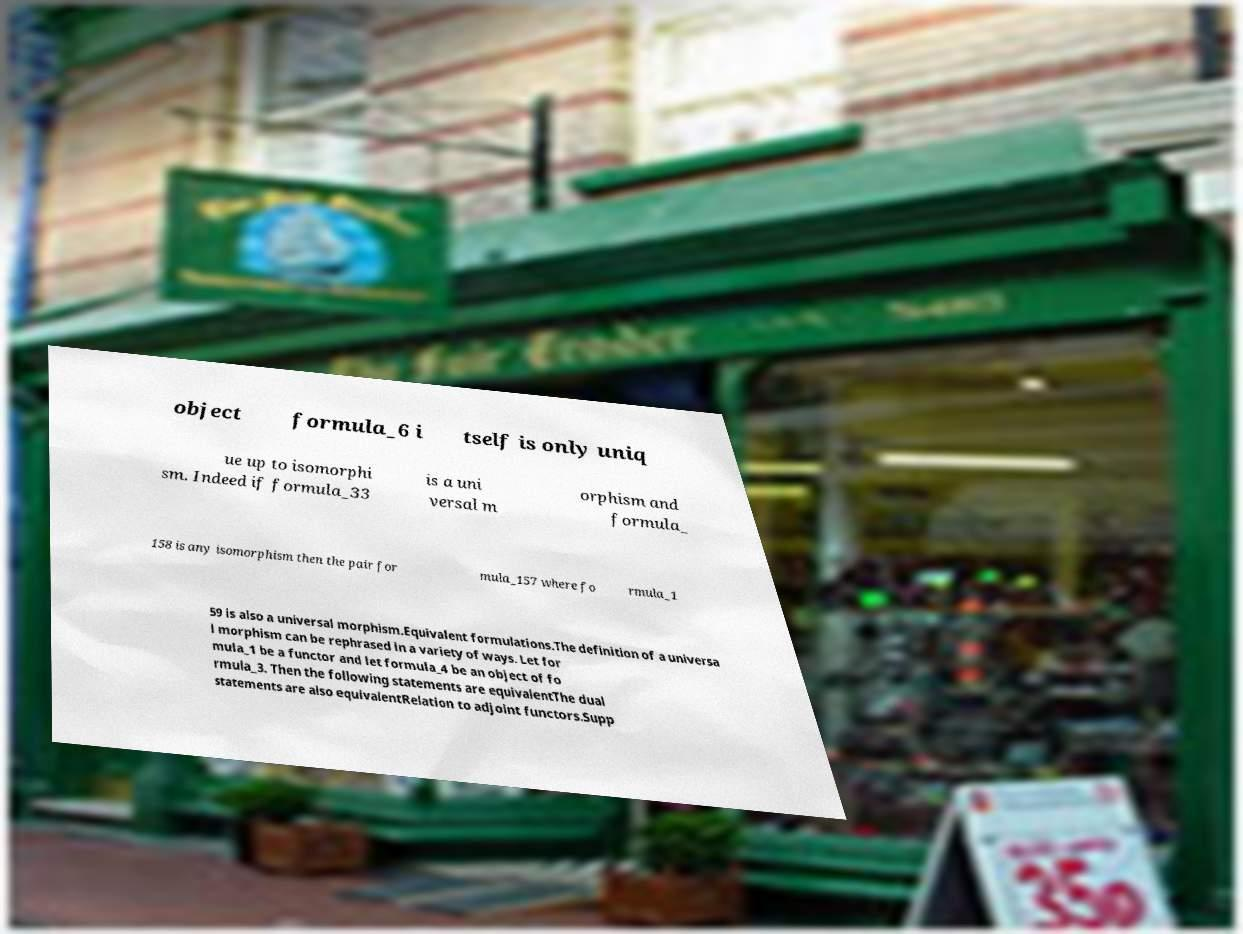Could you extract and type out the text from this image? object formula_6 i tself is only uniq ue up to isomorphi sm. Indeed if formula_33 is a uni versal m orphism and formula_ 158 is any isomorphism then the pair for mula_157 where fo rmula_1 59 is also a universal morphism.Equivalent formulations.The definition of a universa l morphism can be rephrased in a variety of ways. Let for mula_1 be a functor and let formula_4 be an object of fo rmula_3. Then the following statements are equivalentThe dual statements are also equivalentRelation to adjoint functors.Supp 